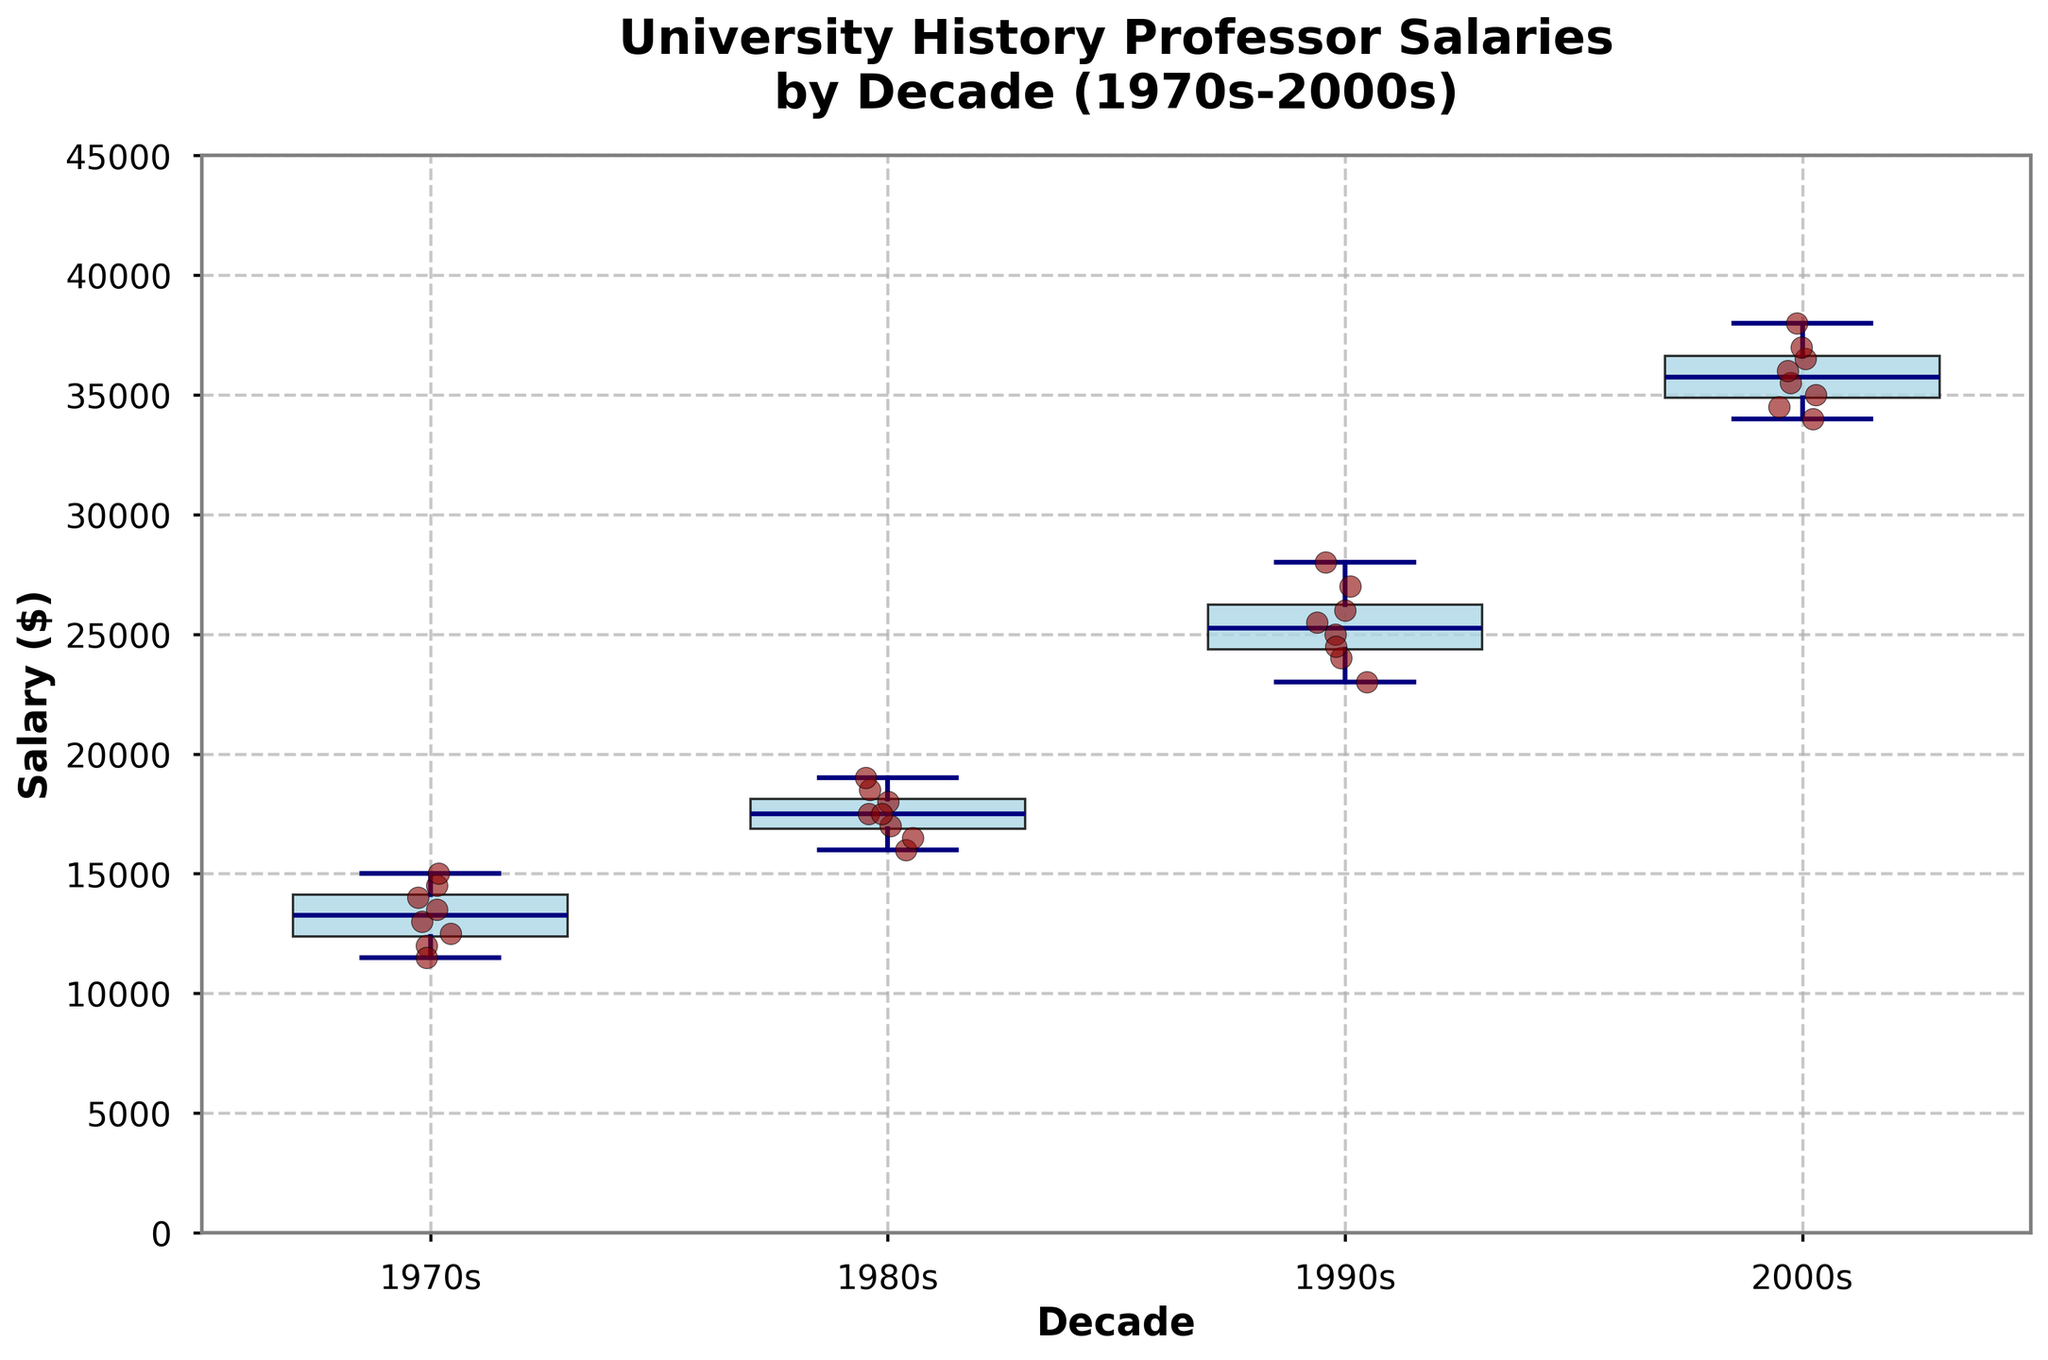What is the title of the figure? The title is displayed at the top of the plot.
Answer: University History Professor Salaries by Decade (1970s-2000s) What is the range of salaries in the 1980s? The range is determined by identifying the minimum and maximum salaries in the 1980s scatter and box plot.
Answer: $16000 to $19000 Which decade shows the highest median salary? The median salary is depicted by the thick horizontal line inside each box plot. The decade with the highest median will show the line at the highest position.
Answer: 2000s How many scatter points are there for the 1990s? Each scatter point represents an individual salary data point. Count the points within the area marked for the 1990s.
Answer: 8 How does the interquartile range (IQR) of the 2000s compare to the 1970s? The IQR is the range between the first quartile (bottom of the box) and the third quartile (top of the box). Compare this range visually between the two decades.
Answer: The IQR for the 2000s is larger What is the median salary difference between the 1990s and the 1970s? Find the median salary for both decades from the median line in the box plots and subtract the 1970s median from the 1990s median.
Answer: $12,000 In which decade did history professors have the highest salary variability? The variability can be observed from the box plot's width (IQR) and the length of the whiskers. Look for the decade with the largest spread in these elements.
Answer: 1980s What does the scatter points' color signify? The scatter points are uniformly colored, which can indicate individual salary points but does not encode additional variables.
Answer: They signify individual salary points Which decade shows the narrowest distribution of salaries? The narrowest distribution will have the smallest IQR and whiskers length in the box plot.
Answer: 1970s Are there any outliers in the salary data for any decade? Outliers in a box plot are usually depicted by points outside the whiskers. Check each decade's spread for points outside the whiskers.
Answer: No 